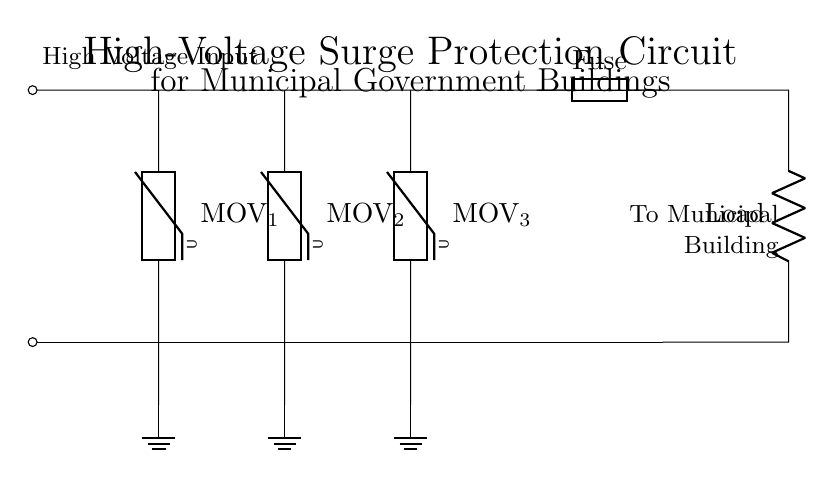What is the main function of the MOVs in the circuit? The Metal Oxide Varistors (MOVs) absorb excess voltage, protecting the circuit and connected equipment from high-voltage surges by clamping them.
Answer: Voltage protection How many MOVs are present in the circuit? There are three MOVs connected in parallel between the high voltage input and ground, providing multiple pathways for surge protection.
Answer: Three What does the fuse do in this circuit? The fuse acts as a safety device that breaks the circuit if the current exceeds a certain limit, preventing damage to the connected load and components.
Answer: Current protection What is the purpose of the ground connections in the circuit? The ground connections allow for excess voltage or fault currents to safely dissipate into the ground, reducing the risk of electrical shock or fire.
Answer: Safety discharge What is the load connected to in the circuit and what does it signify? The load indicates the device or system that utilizes the electrical energy, and its placement signifies that it is downstream of the surge protection components, ensuring that it remains protected.
Answer: Municipal building What will happen if the fuse blows? If the fuse blows, it will disconnect the load from the circuit, preventing any electrical flow and protecting the load from potential damage due to overload or fault conditions.
Answer: Disconnect load 